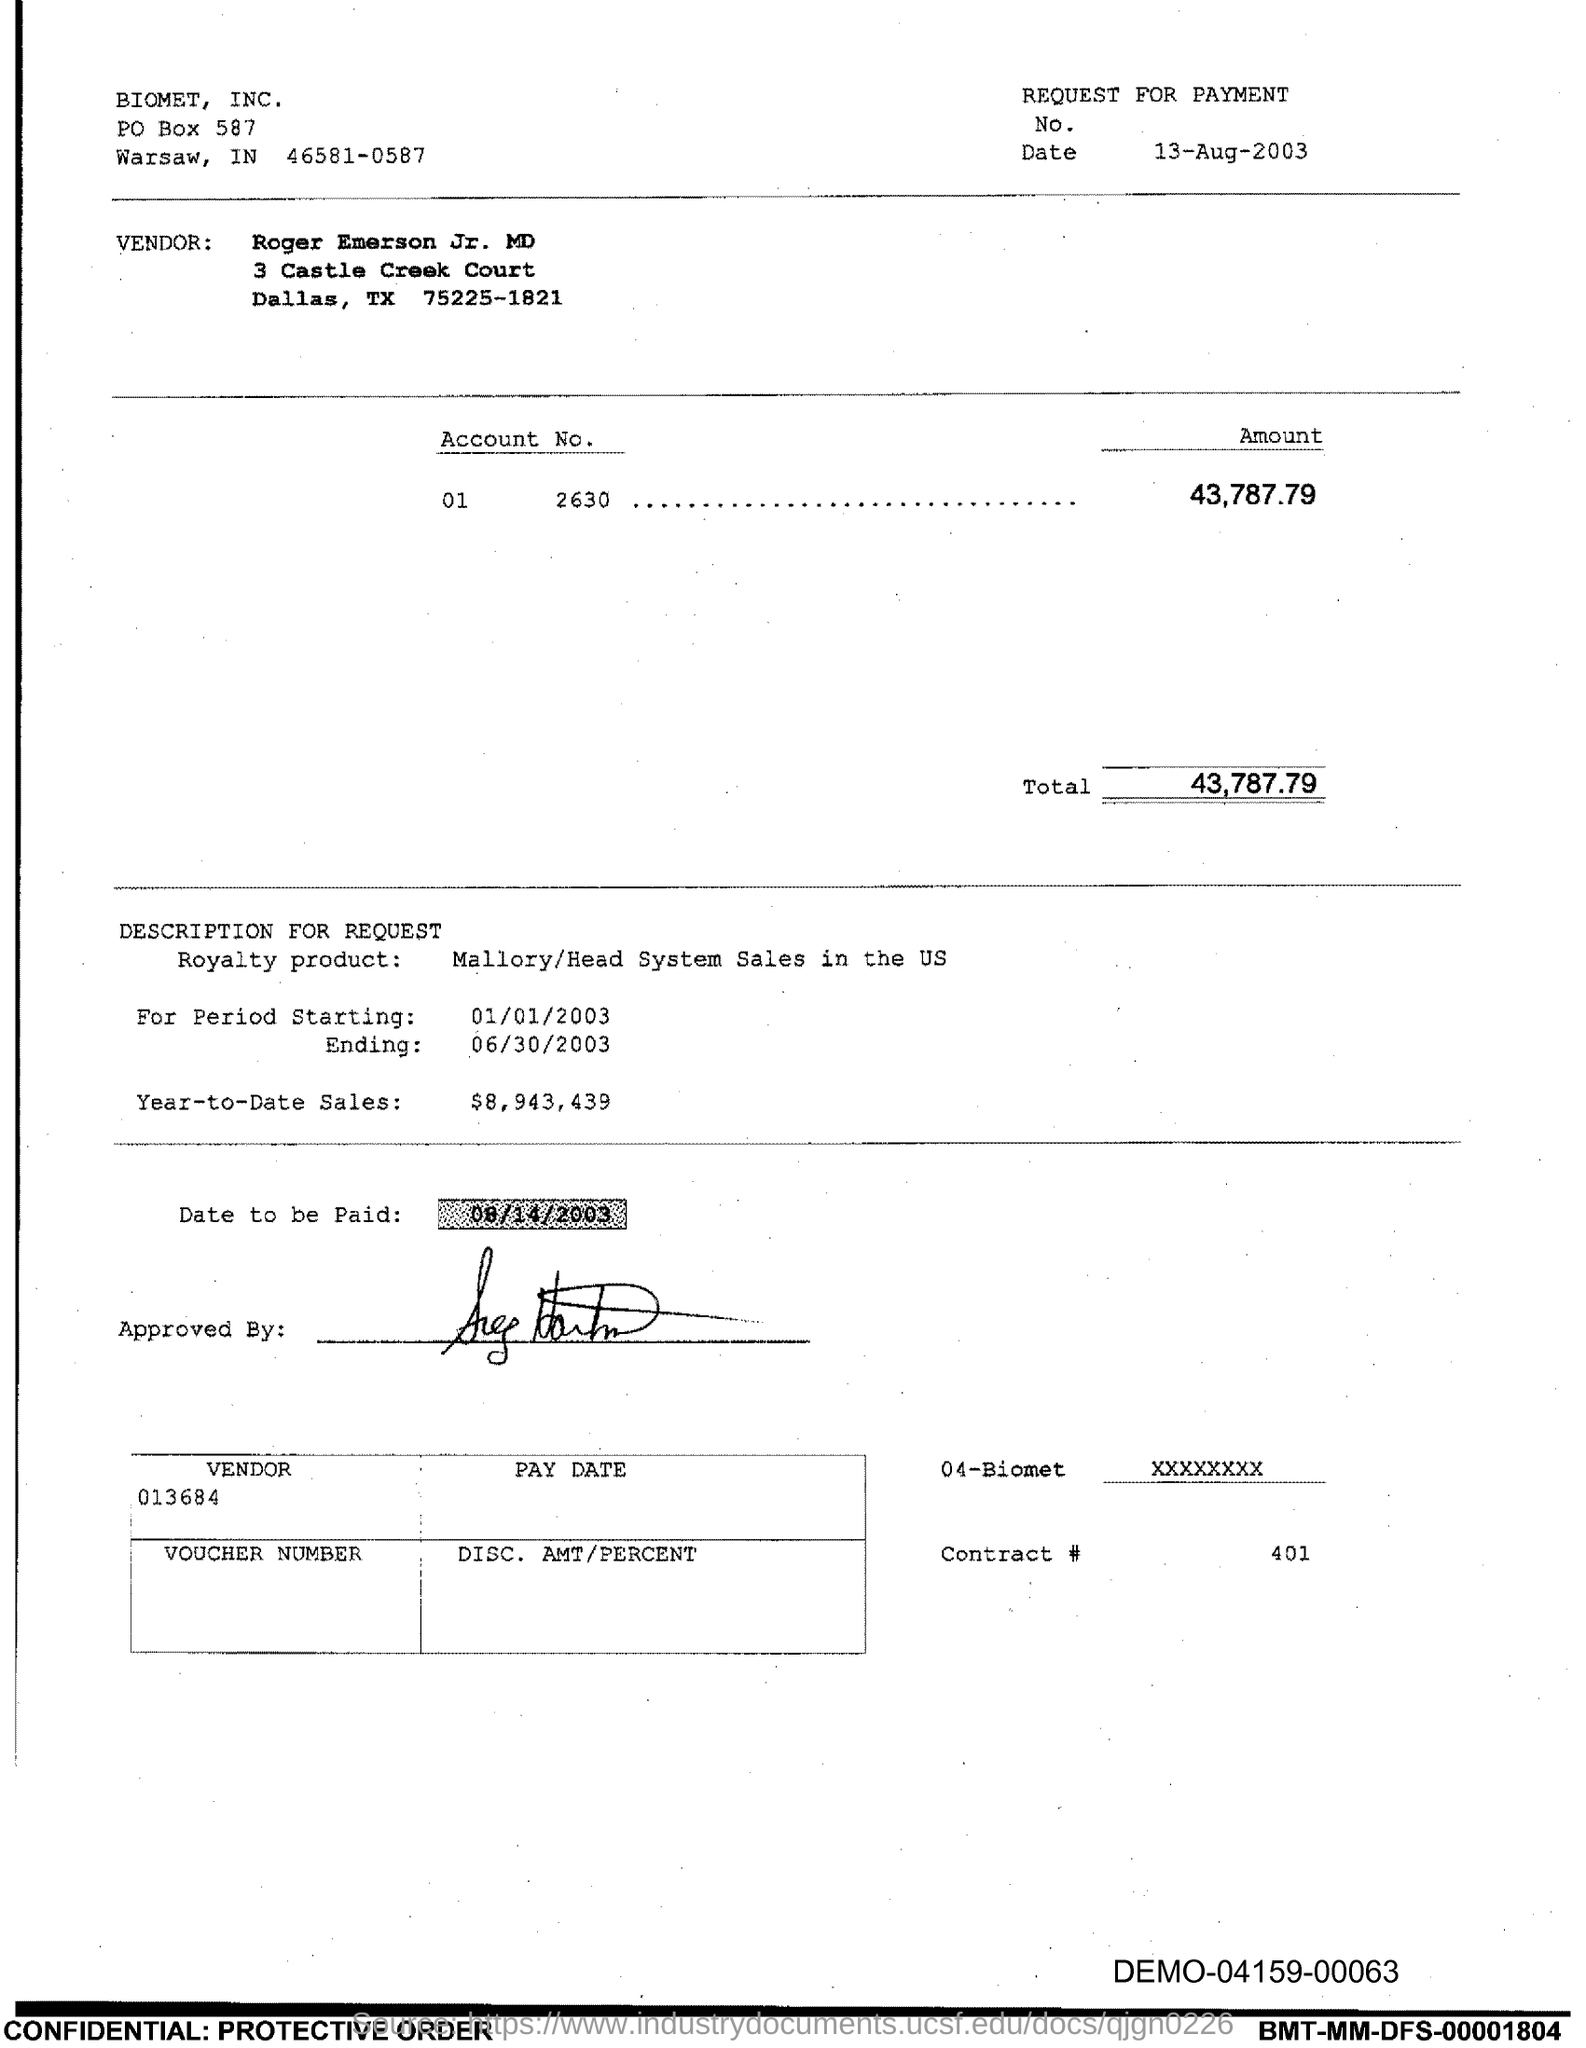What is Contract # number?
Your answer should be very brief. 401. What is the date to be paid mentioned in the document?
Ensure brevity in your answer.  08/14/2003. What is the PO Box Number mentioned in the document?
Ensure brevity in your answer.  587. 